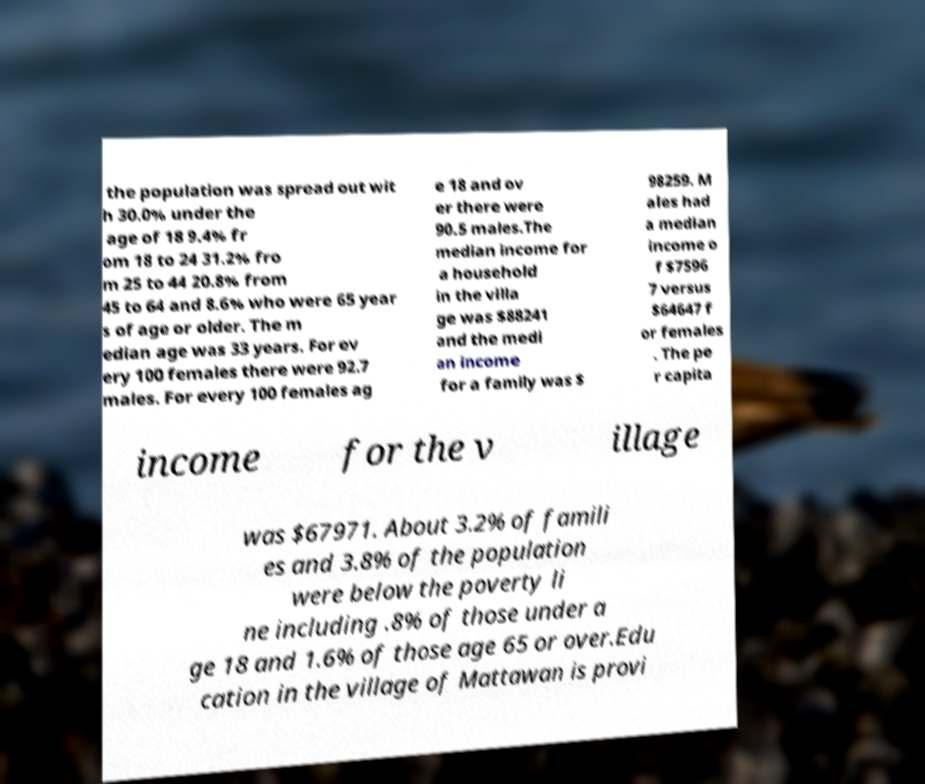What messages or text are displayed in this image? I need them in a readable, typed format. the population was spread out wit h 30.0% under the age of 18 9.4% fr om 18 to 24 31.2% fro m 25 to 44 20.8% from 45 to 64 and 8.6% who were 65 year s of age or older. The m edian age was 33 years. For ev ery 100 females there were 92.7 males. For every 100 females ag e 18 and ov er there were 90.5 males.The median income for a household in the villa ge was $88241 and the medi an income for a family was $ 98259. M ales had a median income o f $7596 7 versus $64647 f or females . The pe r capita income for the v illage was $67971. About 3.2% of famili es and 3.8% of the population were below the poverty li ne including .8% of those under a ge 18 and 1.6% of those age 65 or over.Edu cation in the village of Mattawan is provi 